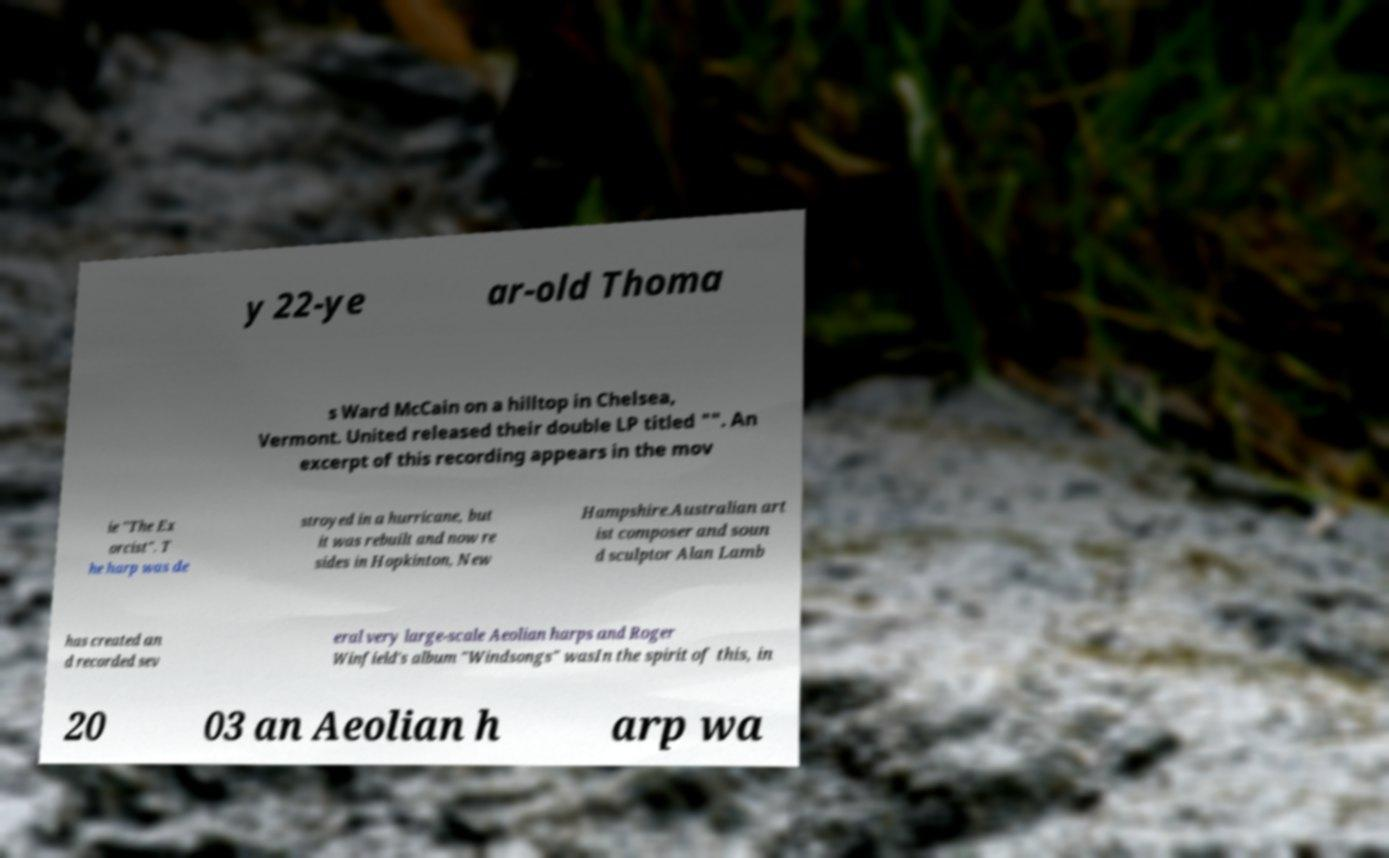For documentation purposes, I need the text within this image transcribed. Could you provide that? y 22-ye ar-old Thoma s Ward McCain on a hilltop in Chelsea, Vermont. United released their double LP titled "". An excerpt of this recording appears in the mov ie "The Ex orcist". T he harp was de stroyed in a hurricane, but it was rebuilt and now re sides in Hopkinton, New Hampshire.Australian art ist composer and soun d sculptor Alan Lamb has created an d recorded sev eral very large-scale Aeolian harps and Roger Winfield's album "Windsongs" wasIn the spirit of this, in 20 03 an Aeolian h arp wa 